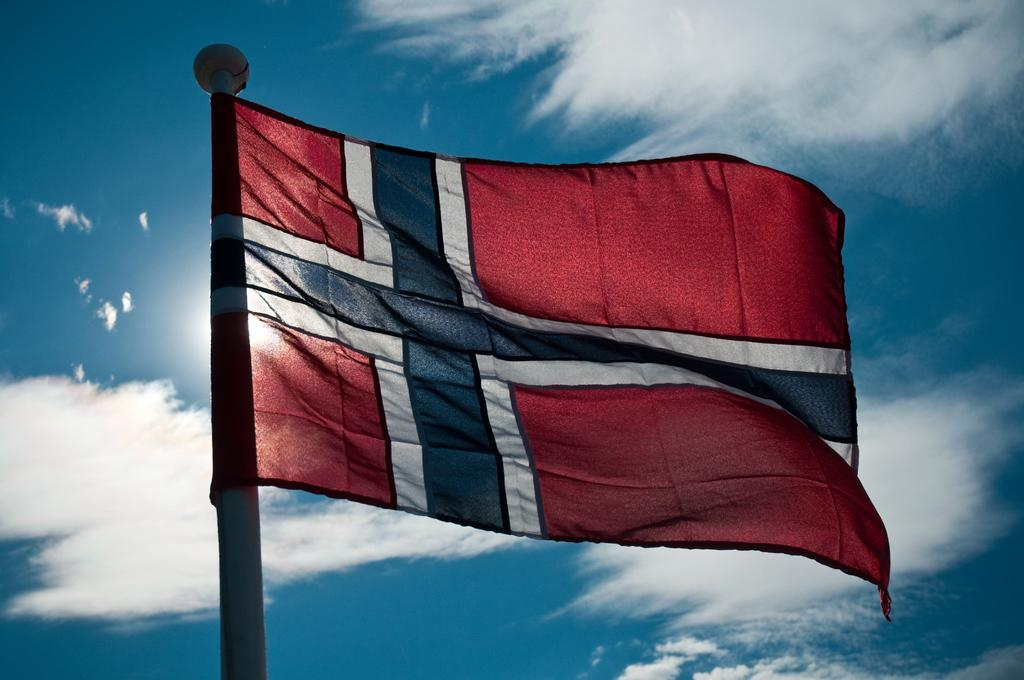Where was the image taken? The image is taken outdoors. What can be seen in the background of the image? There is a sky with clouds in the background of the image. What is the main subject in the middle of the image? There is a flag in the middle of the image. What is supporting the flag in the image? There is a flagpole in the middle of the image. What position does the drawer hold in the image? There is no drawer present in the image. What is the cause of the clouds in the image? The cause of the clouds in the image cannot be determined from the image itself. 